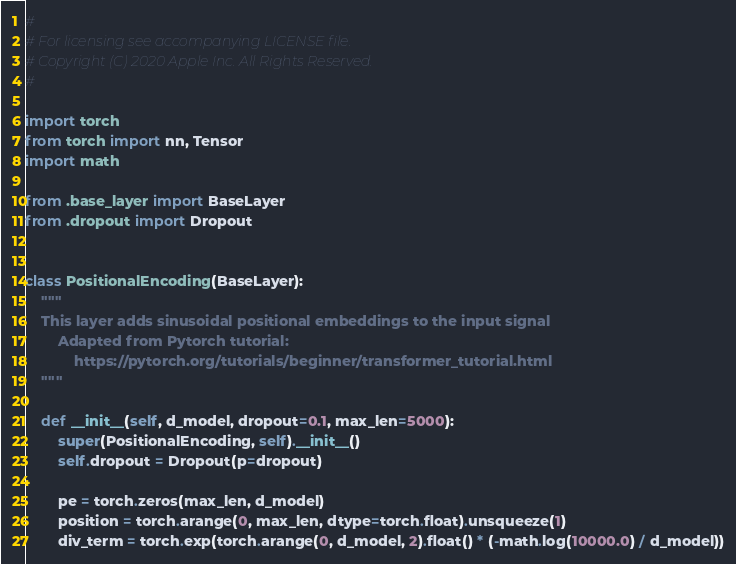<code> <loc_0><loc_0><loc_500><loc_500><_Python_>#
# For licensing see accompanying LICENSE file.
# Copyright (C) 2020 Apple Inc. All Rights Reserved.
#

import torch
from torch import nn, Tensor
import math

from .base_layer import BaseLayer
from .dropout import Dropout


class PositionalEncoding(BaseLayer):
    """
    This layer adds sinusoidal positional embeddings to the input signal
        Adapted from Pytorch tutorial:
            https://pytorch.org/tutorials/beginner/transformer_tutorial.html
    """

    def __init__(self, d_model, dropout=0.1, max_len=5000):
        super(PositionalEncoding, self).__init__()
        self.dropout = Dropout(p=dropout)

        pe = torch.zeros(max_len, d_model)
        position = torch.arange(0, max_len, dtype=torch.float).unsqueeze(1)
        div_term = torch.exp(torch.arange(0, d_model, 2).float() * (-math.log(10000.0) / d_model))</code> 